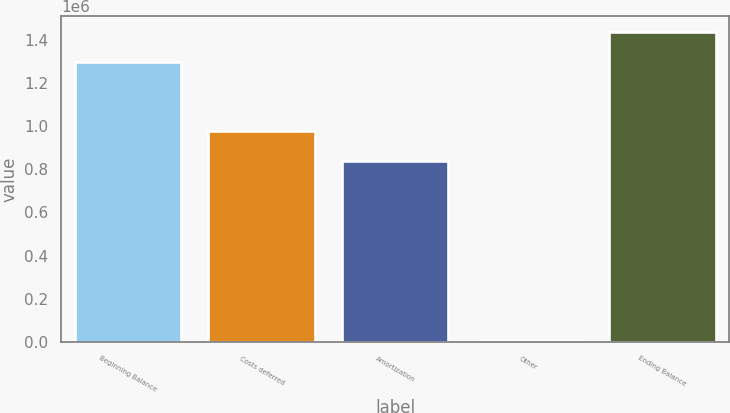<chart> <loc_0><loc_0><loc_500><loc_500><bar_chart><fcel>Beginning Balance<fcel>Costs deferred<fcel>Amortization<fcel>Other<fcel>Ending Balance<nl><fcel>1.2988e+06<fcel>977837<fcel>839799<fcel>4444<fcel>1.43684e+06<nl></chart> 